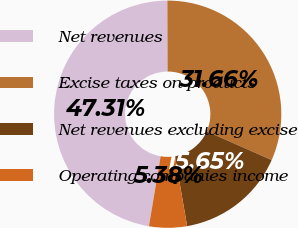<chart> <loc_0><loc_0><loc_500><loc_500><pie_chart><fcel>Net revenues<fcel>Excise taxes on products<fcel>Net revenues excluding excise<fcel>Operating companies income<nl><fcel>47.31%<fcel>31.66%<fcel>15.65%<fcel>5.38%<nl></chart> 